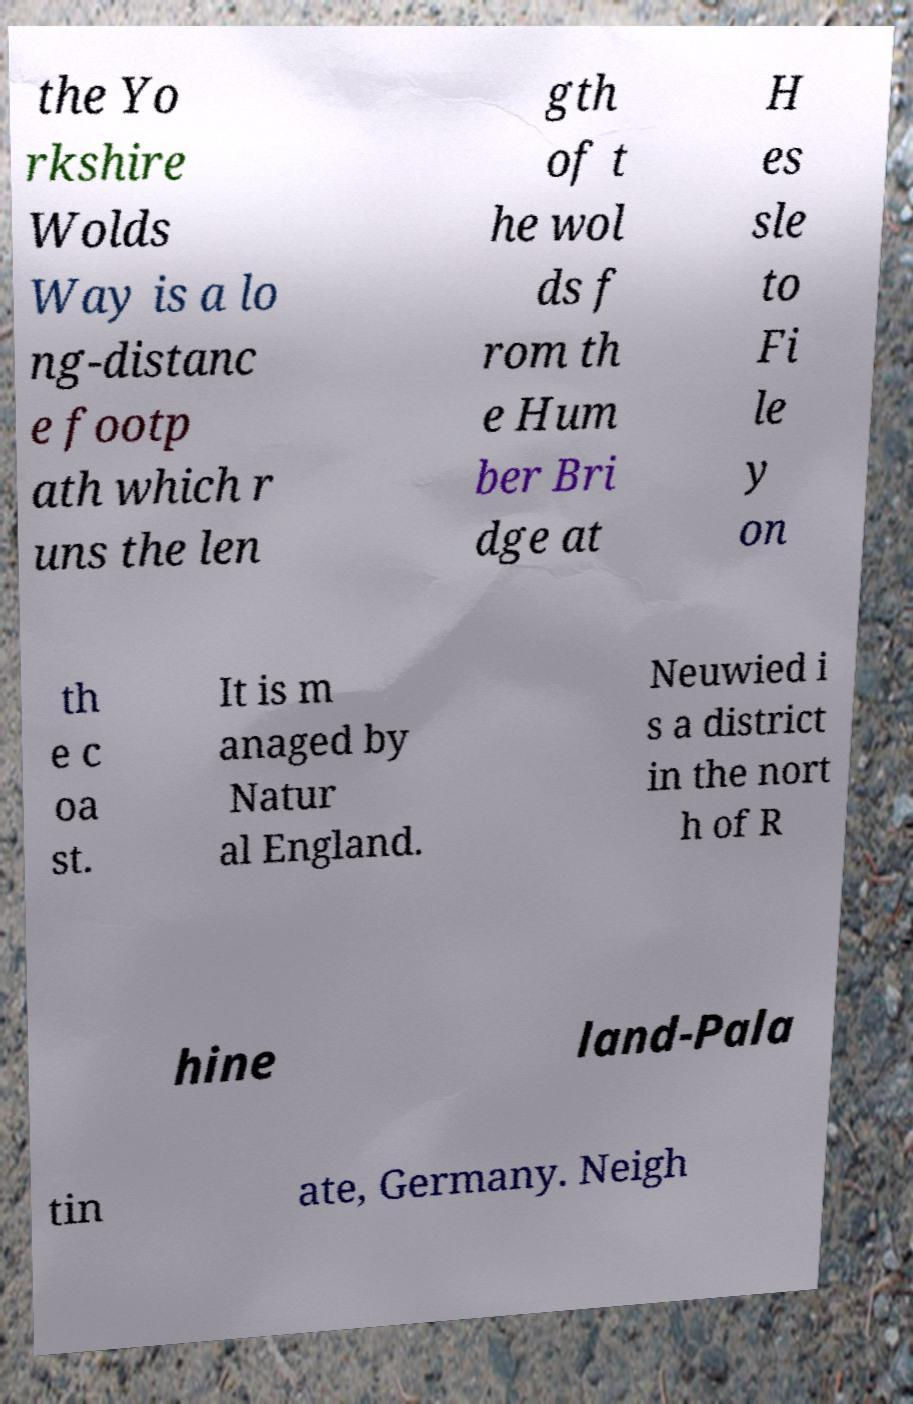There's text embedded in this image that I need extracted. Can you transcribe it verbatim? the Yo rkshire Wolds Way is a lo ng-distanc e footp ath which r uns the len gth of t he wol ds f rom th e Hum ber Bri dge at H es sle to Fi le y on th e c oa st. It is m anaged by Natur al England. Neuwied i s a district in the nort h of R hine land-Pala tin ate, Germany. Neigh 